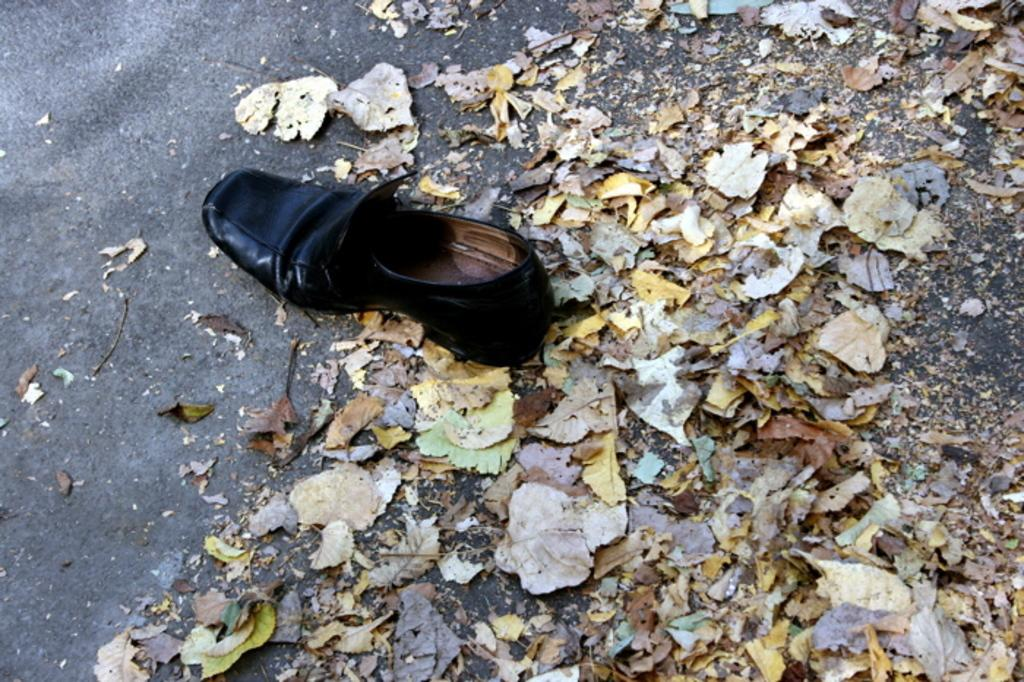What type of footwear is on the road in the image? There is a black shoe on the road in the image. What else can be seen on the road besides the shoe? Dry leaves are present in the image. What day of the week is it in the image? The day of the week is not mentioned or visible in the image. What type of skin is visible on the road in the image? There is no skin visible in the image; it only features a black shoe and dry leaves. 